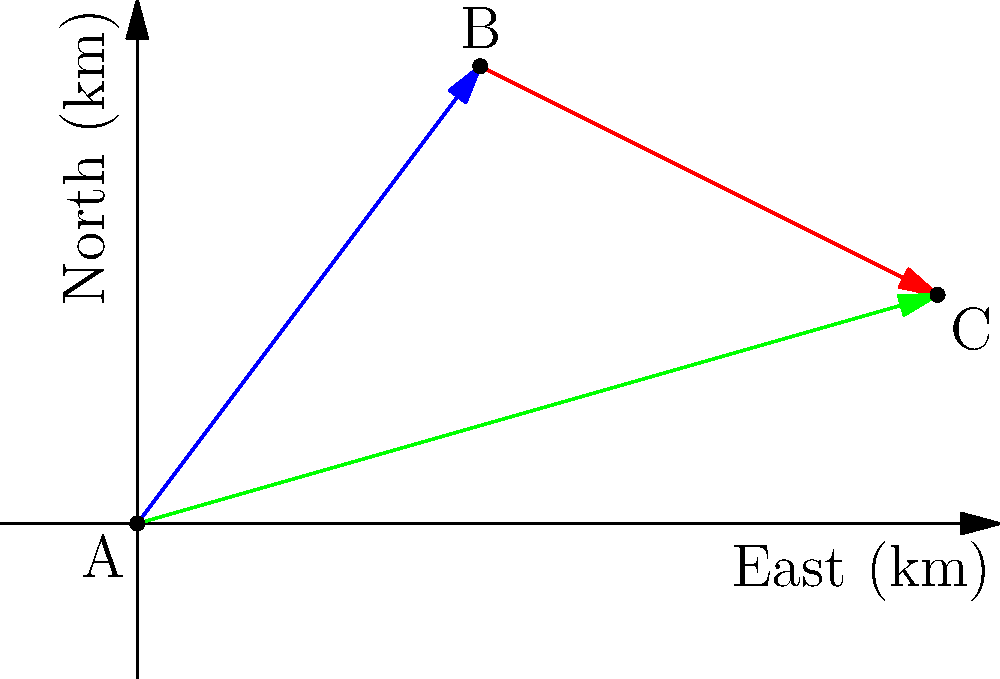As part of a wildlife corridor mapping project, you need to determine the most efficient route for animal migration. Given the vector $\vec{AB} = 3\hat{i} + 4\hat{j}$ km and $\vec{BC} = 4\hat{i} - 2\hat{j}$ km, calculate the magnitude of the resultant vector $\vec{AC}$ representing the direct path from point A to point C. To solve this problem, we'll follow these steps:

1) First, we need to find the components of vector $\vec{AC}$. We can do this by adding the components of $\vec{AB}$ and $\vec{BC}$:

   $\vec{AC} = \vec{AB} + \vec{BC}$

2) Let's add the i-components and j-components separately:
   
   i-component: $3 + 4 = 7$
   j-component: $4 + (-2) = 2$

   So, $\vec{AC} = 7\hat{i} + 2\hat{j}$

3) Now that we have the components of $\vec{AC}$, we can calculate its magnitude using the Pythagorean theorem:

   $|\vec{AC}| = \sqrt{(7)^2 + (2)^2}$

4) Simplify:
   $|\vec{AC}| = \sqrt{49 + 4} = \sqrt{53}$

5) The square root of 53 cannot be simplified further, so this is our final answer.

Therefore, the magnitude of the resultant vector $\vec{AC}$ is $\sqrt{53}$ km.
Answer: $\sqrt{53}$ km 